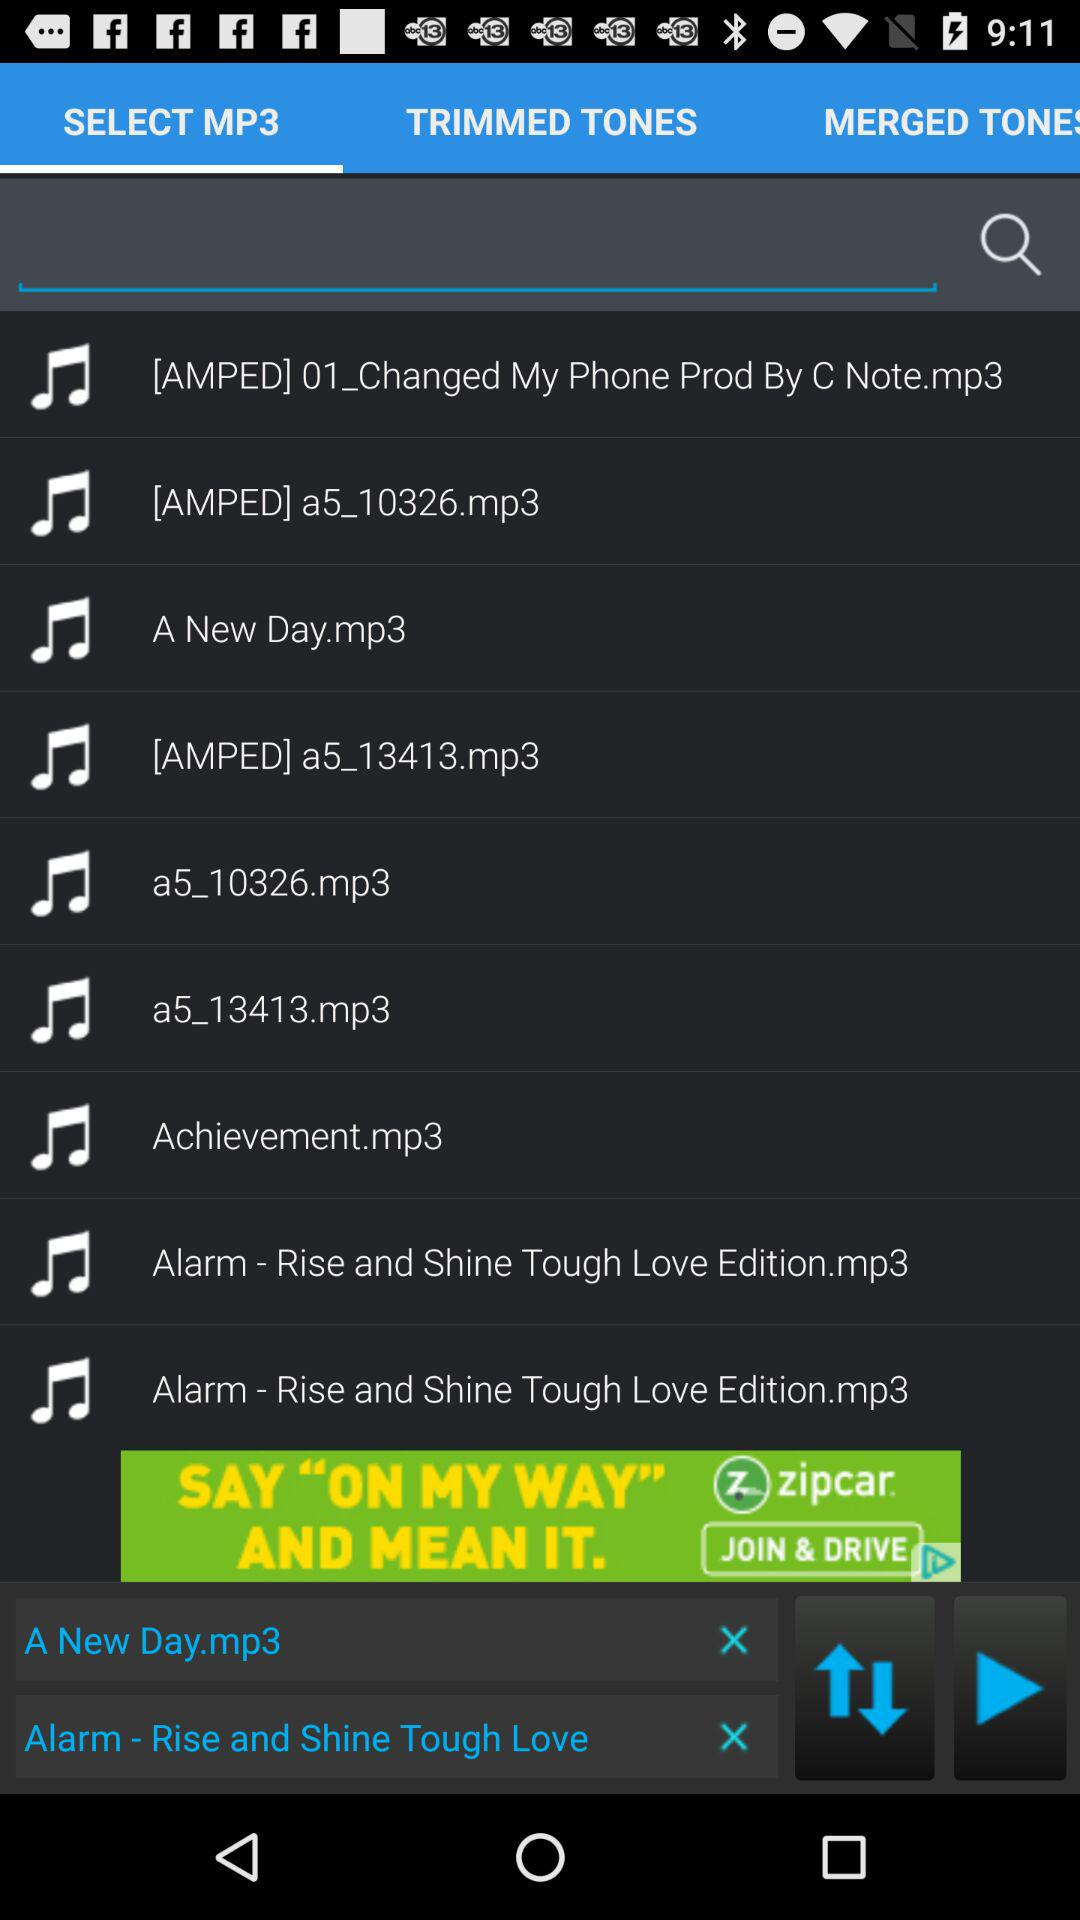Which audio files are in "TRIMMED TONES"?
When the provided information is insufficient, respond with <no answer>. <no answer> 